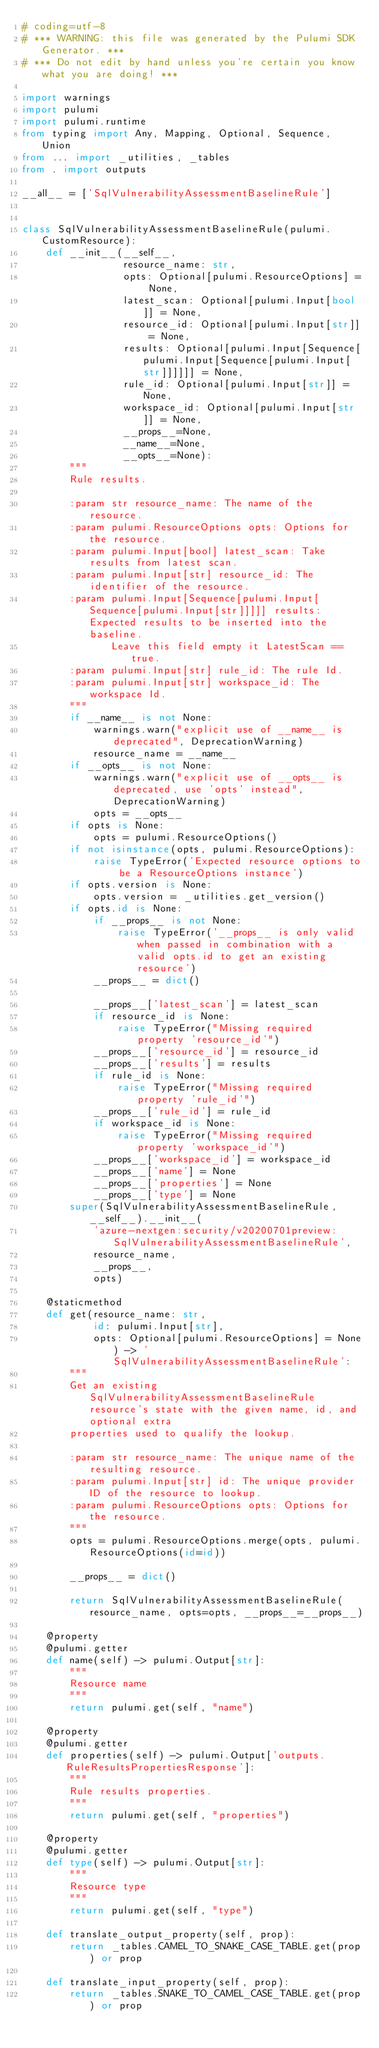<code> <loc_0><loc_0><loc_500><loc_500><_Python_># coding=utf-8
# *** WARNING: this file was generated by the Pulumi SDK Generator. ***
# *** Do not edit by hand unless you're certain you know what you are doing! ***

import warnings
import pulumi
import pulumi.runtime
from typing import Any, Mapping, Optional, Sequence, Union
from ... import _utilities, _tables
from . import outputs

__all__ = ['SqlVulnerabilityAssessmentBaselineRule']


class SqlVulnerabilityAssessmentBaselineRule(pulumi.CustomResource):
    def __init__(__self__,
                 resource_name: str,
                 opts: Optional[pulumi.ResourceOptions] = None,
                 latest_scan: Optional[pulumi.Input[bool]] = None,
                 resource_id: Optional[pulumi.Input[str]] = None,
                 results: Optional[pulumi.Input[Sequence[pulumi.Input[Sequence[pulumi.Input[str]]]]]] = None,
                 rule_id: Optional[pulumi.Input[str]] = None,
                 workspace_id: Optional[pulumi.Input[str]] = None,
                 __props__=None,
                 __name__=None,
                 __opts__=None):
        """
        Rule results.

        :param str resource_name: The name of the resource.
        :param pulumi.ResourceOptions opts: Options for the resource.
        :param pulumi.Input[bool] latest_scan: Take results from latest scan.
        :param pulumi.Input[str] resource_id: The identifier of the resource.
        :param pulumi.Input[Sequence[pulumi.Input[Sequence[pulumi.Input[str]]]]] results: Expected results to be inserted into the baseline.
               Leave this field empty it LatestScan == true.
        :param pulumi.Input[str] rule_id: The rule Id.
        :param pulumi.Input[str] workspace_id: The workspace Id.
        """
        if __name__ is not None:
            warnings.warn("explicit use of __name__ is deprecated", DeprecationWarning)
            resource_name = __name__
        if __opts__ is not None:
            warnings.warn("explicit use of __opts__ is deprecated, use 'opts' instead", DeprecationWarning)
            opts = __opts__
        if opts is None:
            opts = pulumi.ResourceOptions()
        if not isinstance(opts, pulumi.ResourceOptions):
            raise TypeError('Expected resource options to be a ResourceOptions instance')
        if opts.version is None:
            opts.version = _utilities.get_version()
        if opts.id is None:
            if __props__ is not None:
                raise TypeError('__props__ is only valid when passed in combination with a valid opts.id to get an existing resource')
            __props__ = dict()

            __props__['latest_scan'] = latest_scan
            if resource_id is None:
                raise TypeError("Missing required property 'resource_id'")
            __props__['resource_id'] = resource_id
            __props__['results'] = results
            if rule_id is None:
                raise TypeError("Missing required property 'rule_id'")
            __props__['rule_id'] = rule_id
            if workspace_id is None:
                raise TypeError("Missing required property 'workspace_id'")
            __props__['workspace_id'] = workspace_id
            __props__['name'] = None
            __props__['properties'] = None
            __props__['type'] = None
        super(SqlVulnerabilityAssessmentBaselineRule, __self__).__init__(
            'azure-nextgen:security/v20200701preview:SqlVulnerabilityAssessmentBaselineRule',
            resource_name,
            __props__,
            opts)

    @staticmethod
    def get(resource_name: str,
            id: pulumi.Input[str],
            opts: Optional[pulumi.ResourceOptions] = None) -> 'SqlVulnerabilityAssessmentBaselineRule':
        """
        Get an existing SqlVulnerabilityAssessmentBaselineRule resource's state with the given name, id, and optional extra
        properties used to qualify the lookup.

        :param str resource_name: The unique name of the resulting resource.
        :param pulumi.Input[str] id: The unique provider ID of the resource to lookup.
        :param pulumi.ResourceOptions opts: Options for the resource.
        """
        opts = pulumi.ResourceOptions.merge(opts, pulumi.ResourceOptions(id=id))

        __props__ = dict()

        return SqlVulnerabilityAssessmentBaselineRule(resource_name, opts=opts, __props__=__props__)

    @property
    @pulumi.getter
    def name(self) -> pulumi.Output[str]:
        """
        Resource name
        """
        return pulumi.get(self, "name")

    @property
    @pulumi.getter
    def properties(self) -> pulumi.Output['outputs.RuleResultsPropertiesResponse']:
        """
        Rule results properties.
        """
        return pulumi.get(self, "properties")

    @property
    @pulumi.getter
    def type(self) -> pulumi.Output[str]:
        """
        Resource type
        """
        return pulumi.get(self, "type")

    def translate_output_property(self, prop):
        return _tables.CAMEL_TO_SNAKE_CASE_TABLE.get(prop) or prop

    def translate_input_property(self, prop):
        return _tables.SNAKE_TO_CAMEL_CASE_TABLE.get(prop) or prop

</code> 